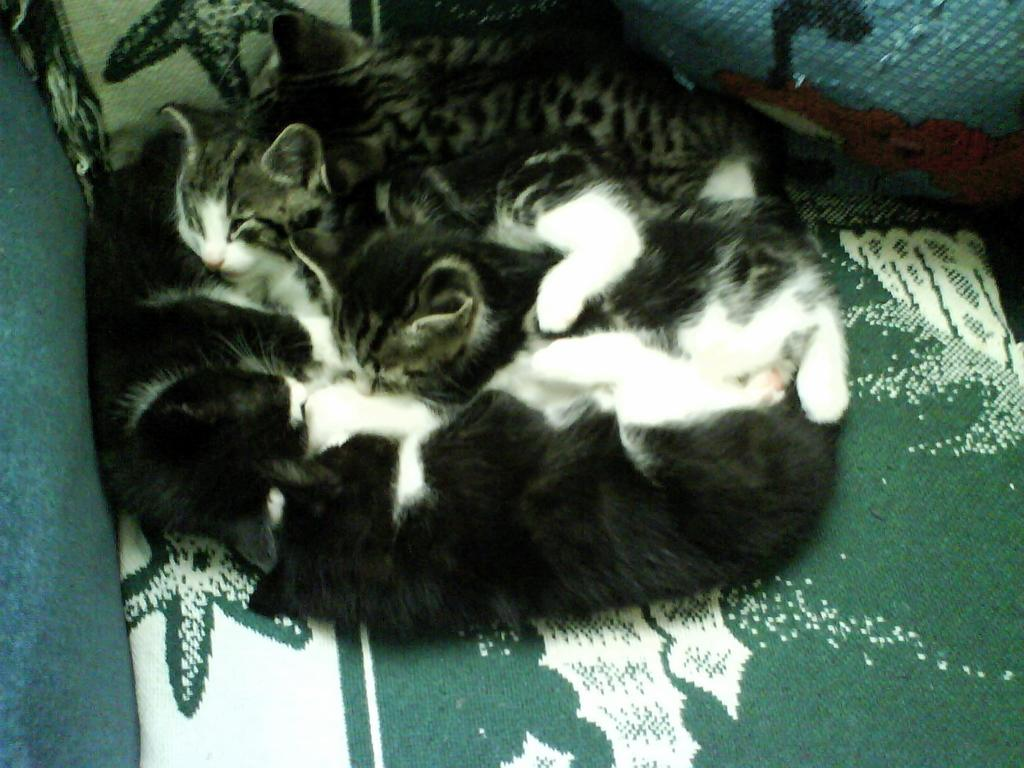Where was the image taken? The image was taken indoors. What piece of furniture is present in the image? There is a couch in the image. What type of animals can be seen on the couch? There are a few cats lying on the couch. What type of jam is being spread on the question in the image? There is no jam or question present in the image; it features a couch with cats lying on it. 